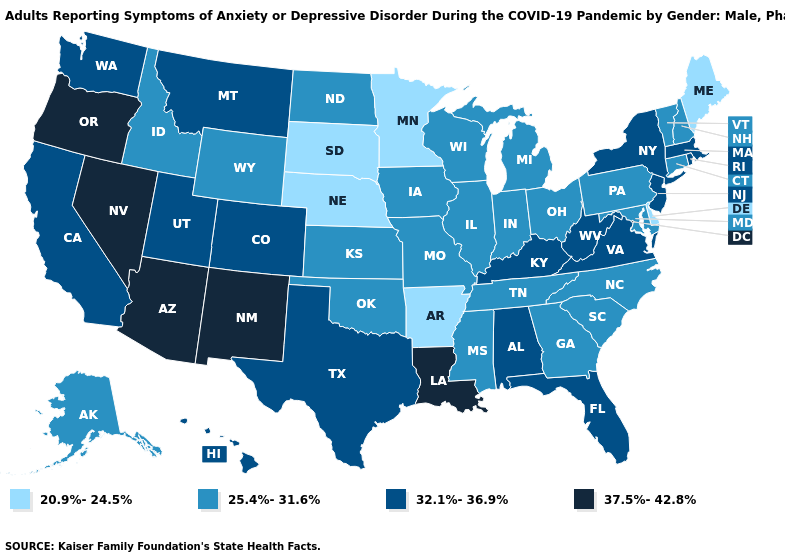Does South Dakota have the lowest value in the USA?
Quick response, please. Yes. What is the value of Ohio?
Answer briefly. 25.4%-31.6%. Among the states that border Wyoming , does Colorado have the highest value?
Quick response, please. Yes. Which states hav the highest value in the Northeast?
Quick response, please. Massachusetts, New Jersey, New York, Rhode Island. What is the lowest value in the USA?
Write a very short answer. 20.9%-24.5%. What is the value of Arizona?
Quick response, please. 37.5%-42.8%. What is the value of South Carolina?
Keep it brief. 25.4%-31.6%. What is the highest value in the MidWest ?
Be succinct. 25.4%-31.6%. What is the lowest value in states that border Maine?
Give a very brief answer. 25.4%-31.6%. Does South Carolina have the lowest value in the USA?
Concise answer only. No. Which states hav the highest value in the South?
Give a very brief answer. Louisiana. Name the states that have a value in the range 32.1%-36.9%?
Write a very short answer. Alabama, California, Colorado, Florida, Hawaii, Kentucky, Massachusetts, Montana, New Jersey, New York, Rhode Island, Texas, Utah, Virginia, Washington, West Virginia. What is the highest value in the USA?
Short answer required. 37.5%-42.8%. Does Michigan have the same value as West Virginia?
Write a very short answer. No. What is the value of Tennessee?
Short answer required. 25.4%-31.6%. 